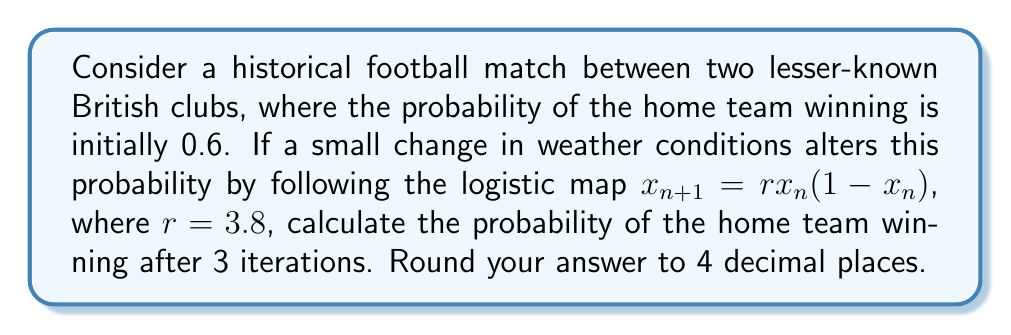Teach me how to tackle this problem. To solve this problem, we'll use the logistic map equation and iterate it 3 times:

1. Initial probability: $x_0 = 0.6$

2. First iteration:
   $x_1 = r \cdot x_0 \cdot (1-x_0)$
   $x_1 = 3.8 \cdot 0.6 \cdot (1-0.6)$
   $x_1 = 3.8 \cdot 0.6 \cdot 0.4 = 0.912$

3. Second iteration:
   $x_2 = r \cdot x_1 \cdot (1-x_1)$
   $x_2 = 3.8 \cdot 0.912 \cdot (1-0.912)$
   $x_2 = 3.8 \cdot 0.912 \cdot 0.088 = 0.304704$

4. Third iteration:
   $x_3 = r \cdot x_2 \cdot (1-x_2)$
   $x_3 = 3.8 \cdot 0.304704 \cdot (1-0.304704)$
   $x_3 = 3.8 \cdot 0.304704 \cdot 0.695296 = 0.8044207424$

5. Rounding to 4 decimal places:
   $0.8044207424 \approx 0.8044$
Answer: 0.8044 